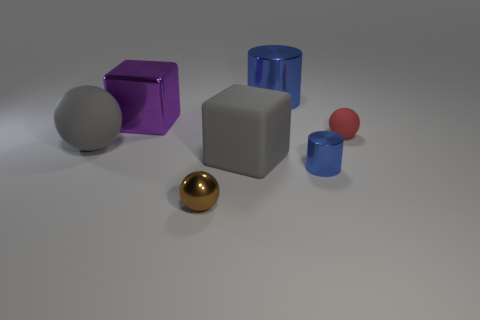What size is the matte block that is the same color as the large sphere?
Ensure brevity in your answer.  Large. What number of balls are gray things or tiny purple objects?
Your answer should be compact. 1. Is the number of purple blocks right of the red matte object greater than the number of red objects that are in front of the small brown metal sphere?
Provide a short and direct response. No. What number of small balls have the same color as the big shiny cylinder?
Provide a short and direct response. 0. What is the size of the red sphere that is made of the same material as the gray block?
Provide a short and direct response. Small. How many objects are either blue metal things behind the small red rubber thing or green cylinders?
Your answer should be very brief. 1. There is a rubber thing that is to the left of the tiny brown sphere; does it have the same color as the metal ball?
Your answer should be compact. No. The red object that is the same shape as the small brown object is what size?
Provide a succinct answer. Small. The ball that is in front of the tiny blue thing that is on the right side of the big gray ball that is to the left of the gray cube is what color?
Provide a short and direct response. Brown. Are the gray cube and the tiny red sphere made of the same material?
Your answer should be very brief. Yes. 